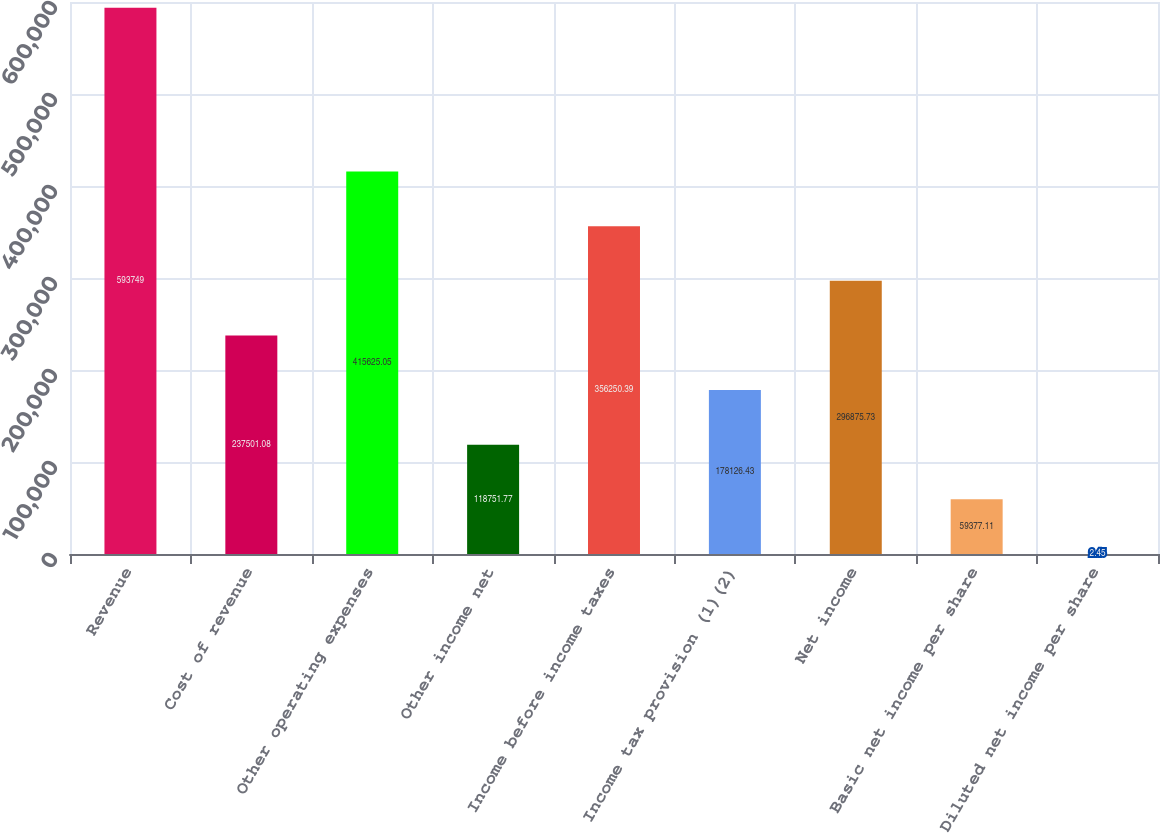<chart> <loc_0><loc_0><loc_500><loc_500><bar_chart><fcel>Revenue<fcel>Cost of revenue<fcel>Other operating expenses<fcel>Other income net<fcel>Income before income taxes<fcel>Income tax provision (1)(2)<fcel>Net income<fcel>Basic net income per share<fcel>Diluted net income per share<nl><fcel>593749<fcel>237501<fcel>415625<fcel>118752<fcel>356250<fcel>178126<fcel>296876<fcel>59377.1<fcel>2.45<nl></chart> 